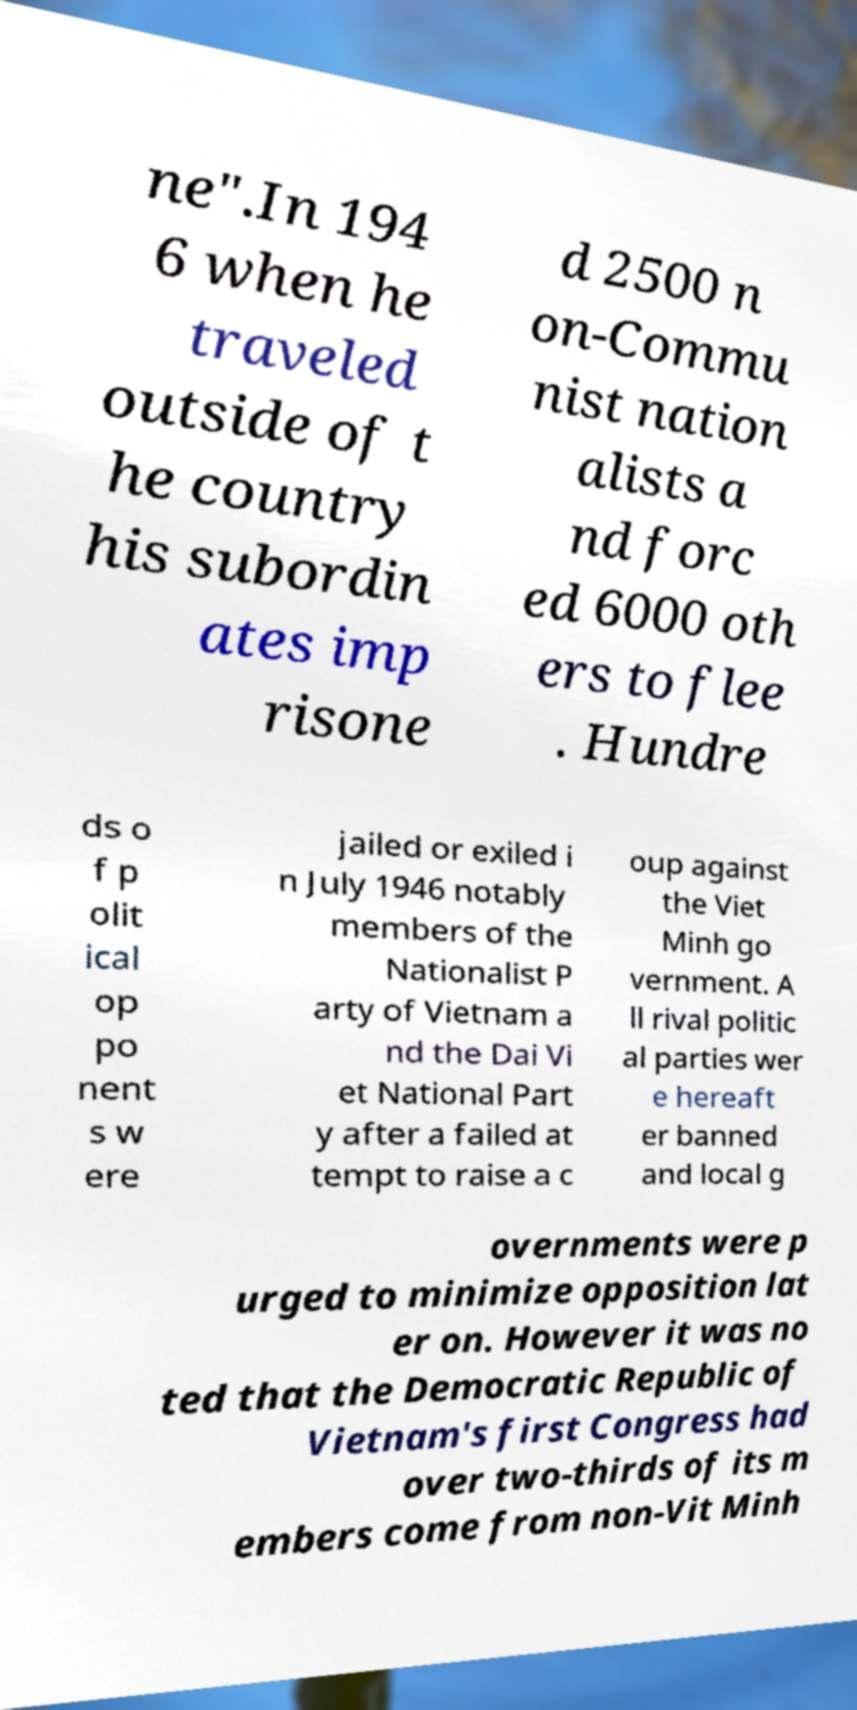Can you read and provide the text displayed in the image?This photo seems to have some interesting text. Can you extract and type it out for me? ne".In 194 6 when he traveled outside of t he country his subordin ates imp risone d 2500 n on-Commu nist nation alists a nd forc ed 6000 oth ers to flee . Hundre ds o f p olit ical op po nent s w ere jailed or exiled i n July 1946 notably members of the Nationalist P arty of Vietnam a nd the Dai Vi et National Part y after a failed at tempt to raise a c oup against the Viet Minh go vernment. A ll rival politic al parties wer e hereaft er banned and local g overnments were p urged to minimize opposition lat er on. However it was no ted that the Democratic Republic of Vietnam's first Congress had over two-thirds of its m embers come from non-Vit Minh 